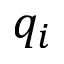<formula> <loc_0><loc_0><loc_500><loc_500>q _ { i }</formula> 